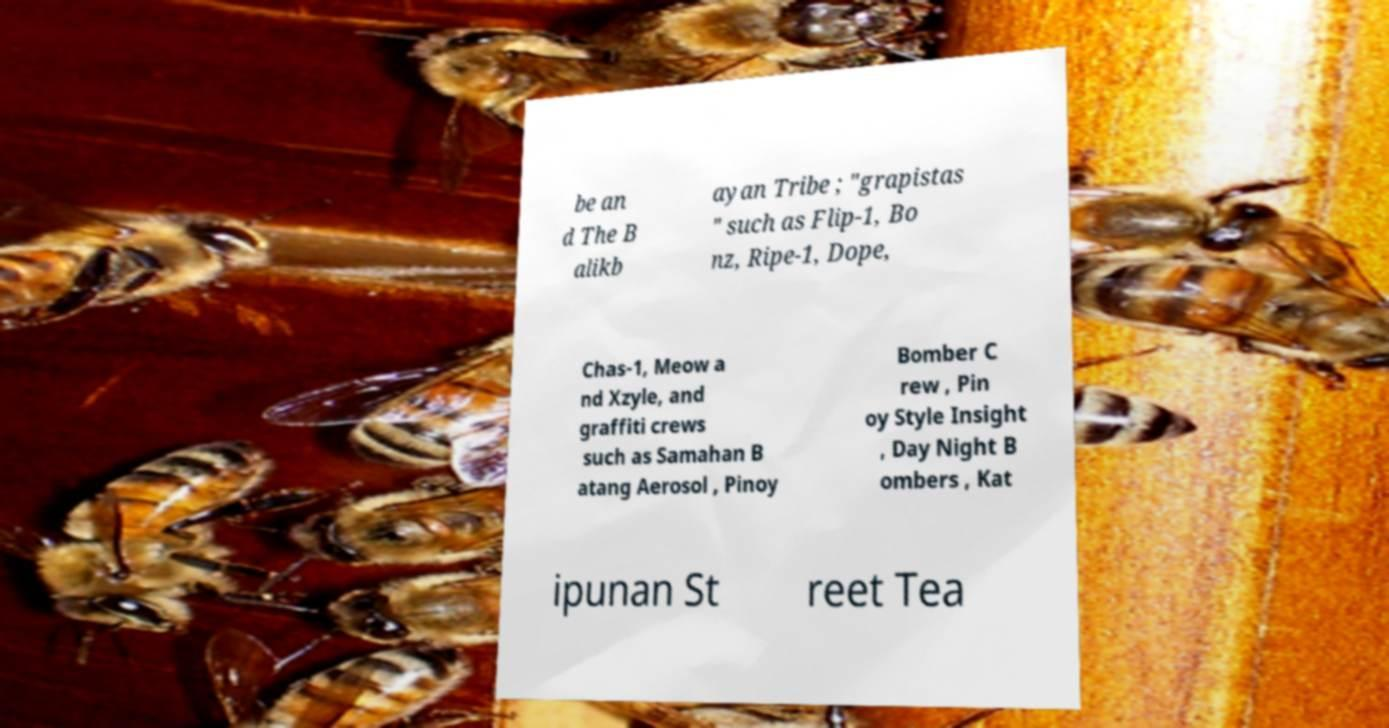I need the written content from this picture converted into text. Can you do that? be an d The B alikb ayan Tribe ; "grapistas " such as Flip-1, Bo nz, Ripe-1, Dope, Chas-1, Meow a nd Xzyle, and graffiti crews such as Samahan B atang Aerosol , Pinoy Bomber C rew , Pin oy Style Insight , Day Night B ombers , Kat ipunan St reet Tea 